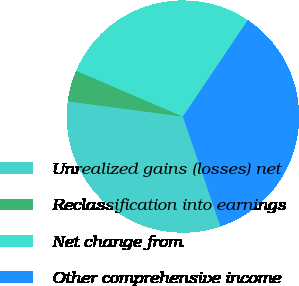Convert chart. <chart><loc_0><loc_0><loc_500><loc_500><pie_chart><fcel>Unrealized gains (losses) net<fcel>Reclassification into earnings<fcel>Net change from<fcel>Other comprehensive income<nl><fcel>32.34%<fcel>4.36%<fcel>27.98%<fcel>35.32%<nl></chart> 